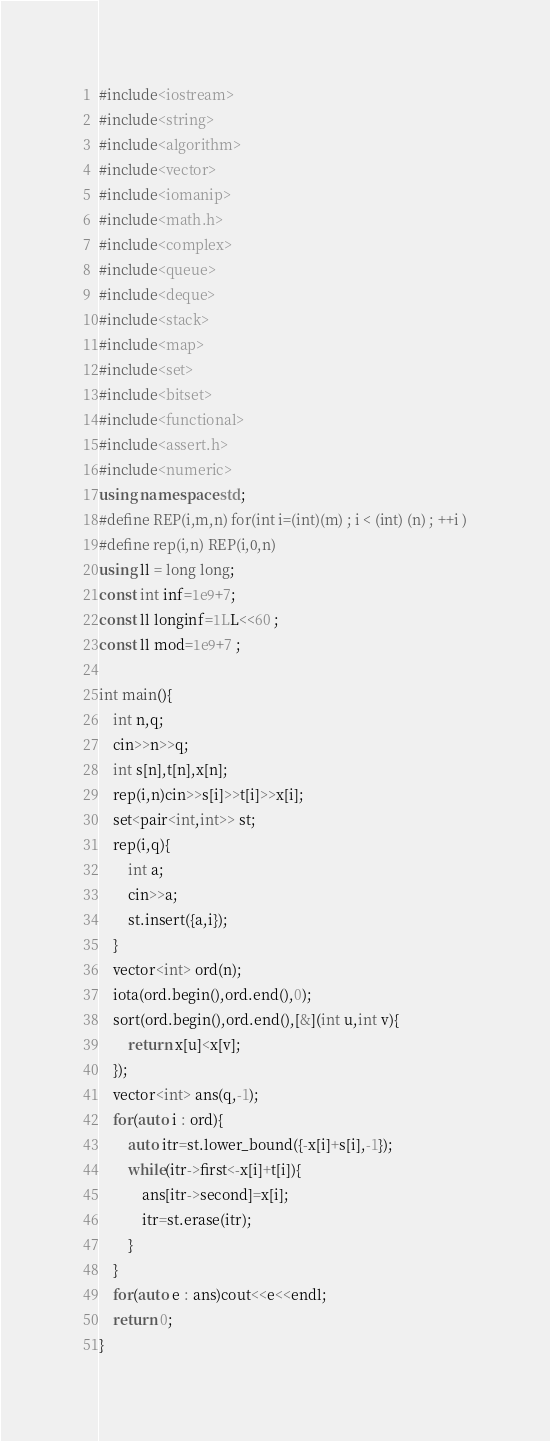<code> <loc_0><loc_0><loc_500><loc_500><_C++_>#include<iostream>
#include<string>
#include<algorithm>
#include<vector>
#include<iomanip>
#include<math.h>
#include<complex>
#include<queue>
#include<deque>
#include<stack>
#include<map>
#include<set>
#include<bitset>
#include<functional>
#include<assert.h>
#include<numeric>
using namespace std;
#define REP(i,m,n) for(int i=(int)(m) ; i < (int) (n) ; ++i )
#define rep(i,n) REP(i,0,n)
using ll = long long;
const int inf=1e9+7;
const ll longinf=1LL<<60 ;
const ll mod=1e9+7 ;

int main(){
	int n,q;
	cin>>n>>q;
	int s[n],t[n],x[n];
	rep(i,n)cin>>s[i]>>t[i]>>x[i];
	set<pair<int,int>> st;
	rep(i,q){
		int a;
		cin>>a;
		st.insert({a,i});
	}
	vector<int> ord(n);
	iota(ord.begin(),ord.end(),0);
	sort(ord.begin(),ord.end(),[&](int u,int v){
		return x[u]<x[v];
	});
	vector<int> ans(q,-1);
	for(auto i : ord){
		auto itr=st.lower_bound({-x[i]+s[i],-1});
		while(itr->first<-x[i]+t[i]){
			ans[itr->second]=x[i];
			itr=st.erase(itr);
		}
	}
	for(auto e : ans)cout<<e<<endl;
	return 0;
}</code> 